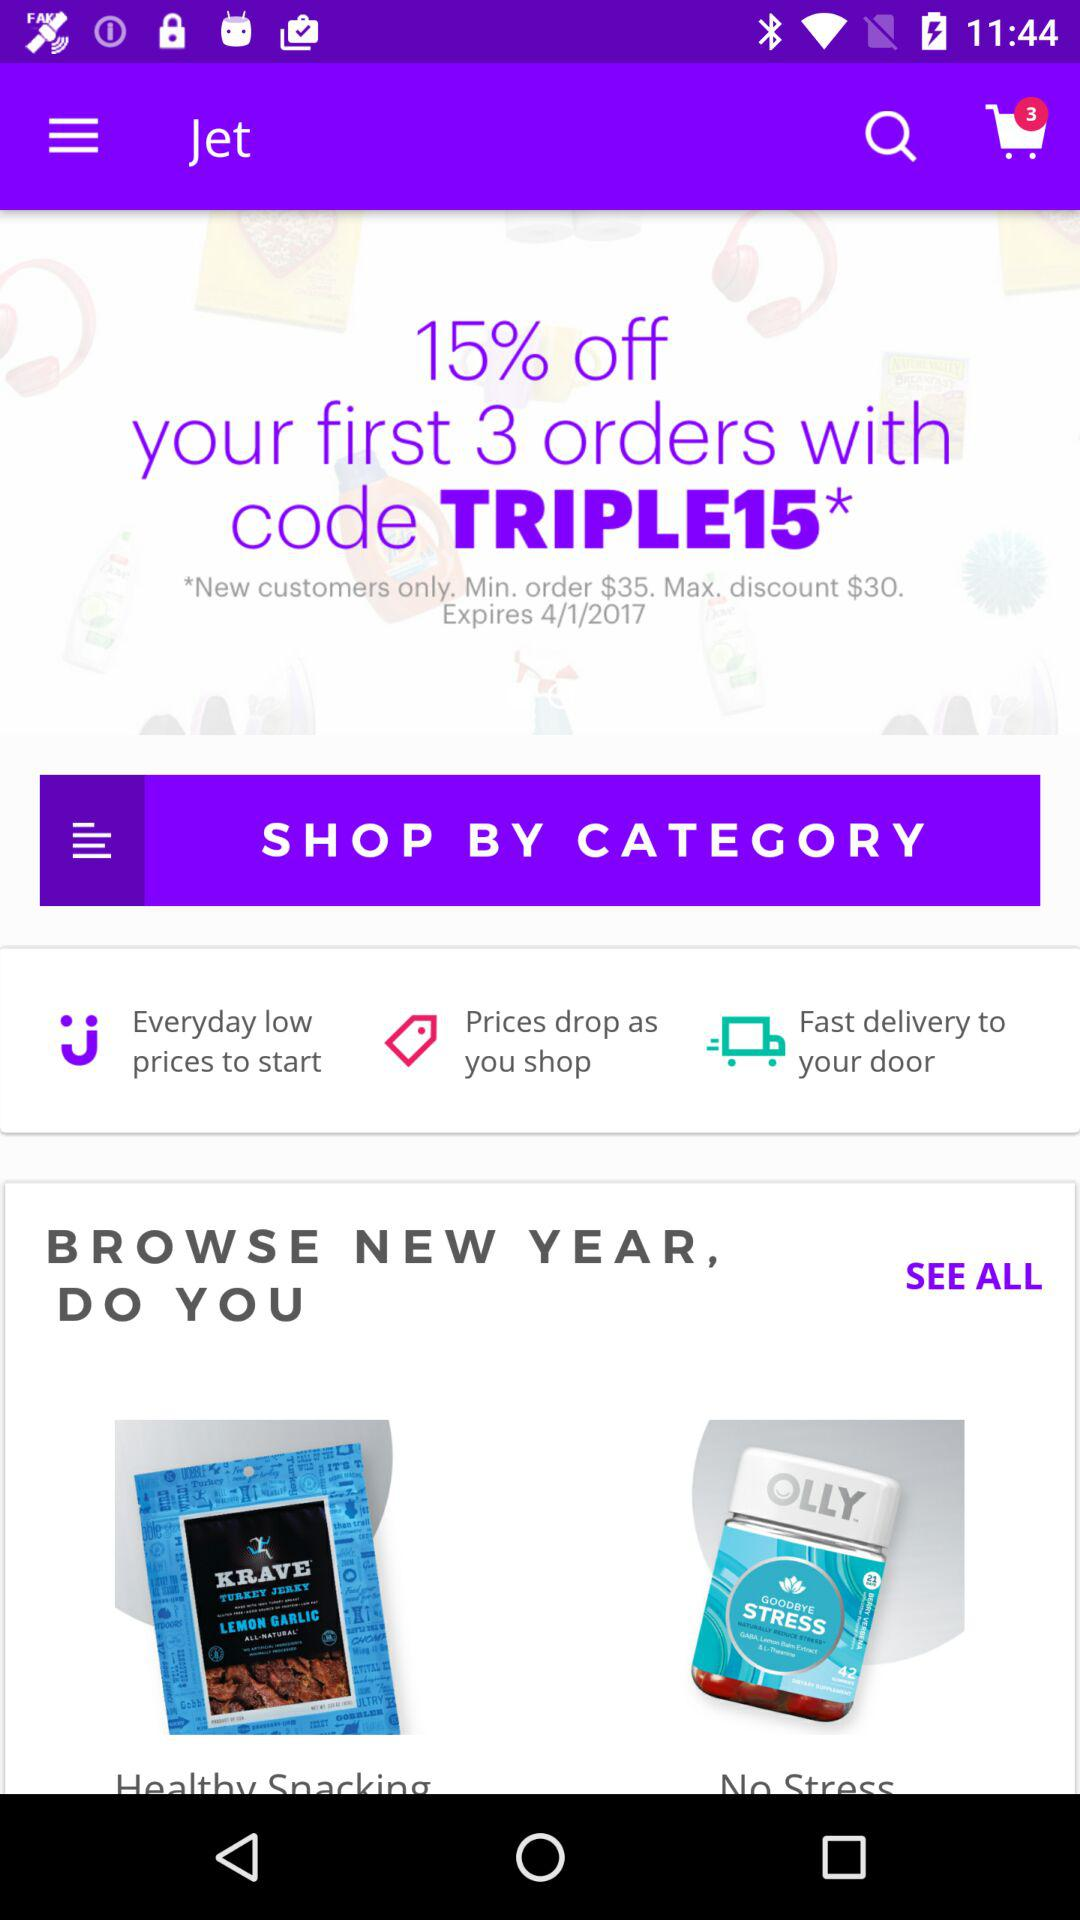How much of a percentage is off on the first 3 orders? The percentage that is off on the first 3 orders is 15. 